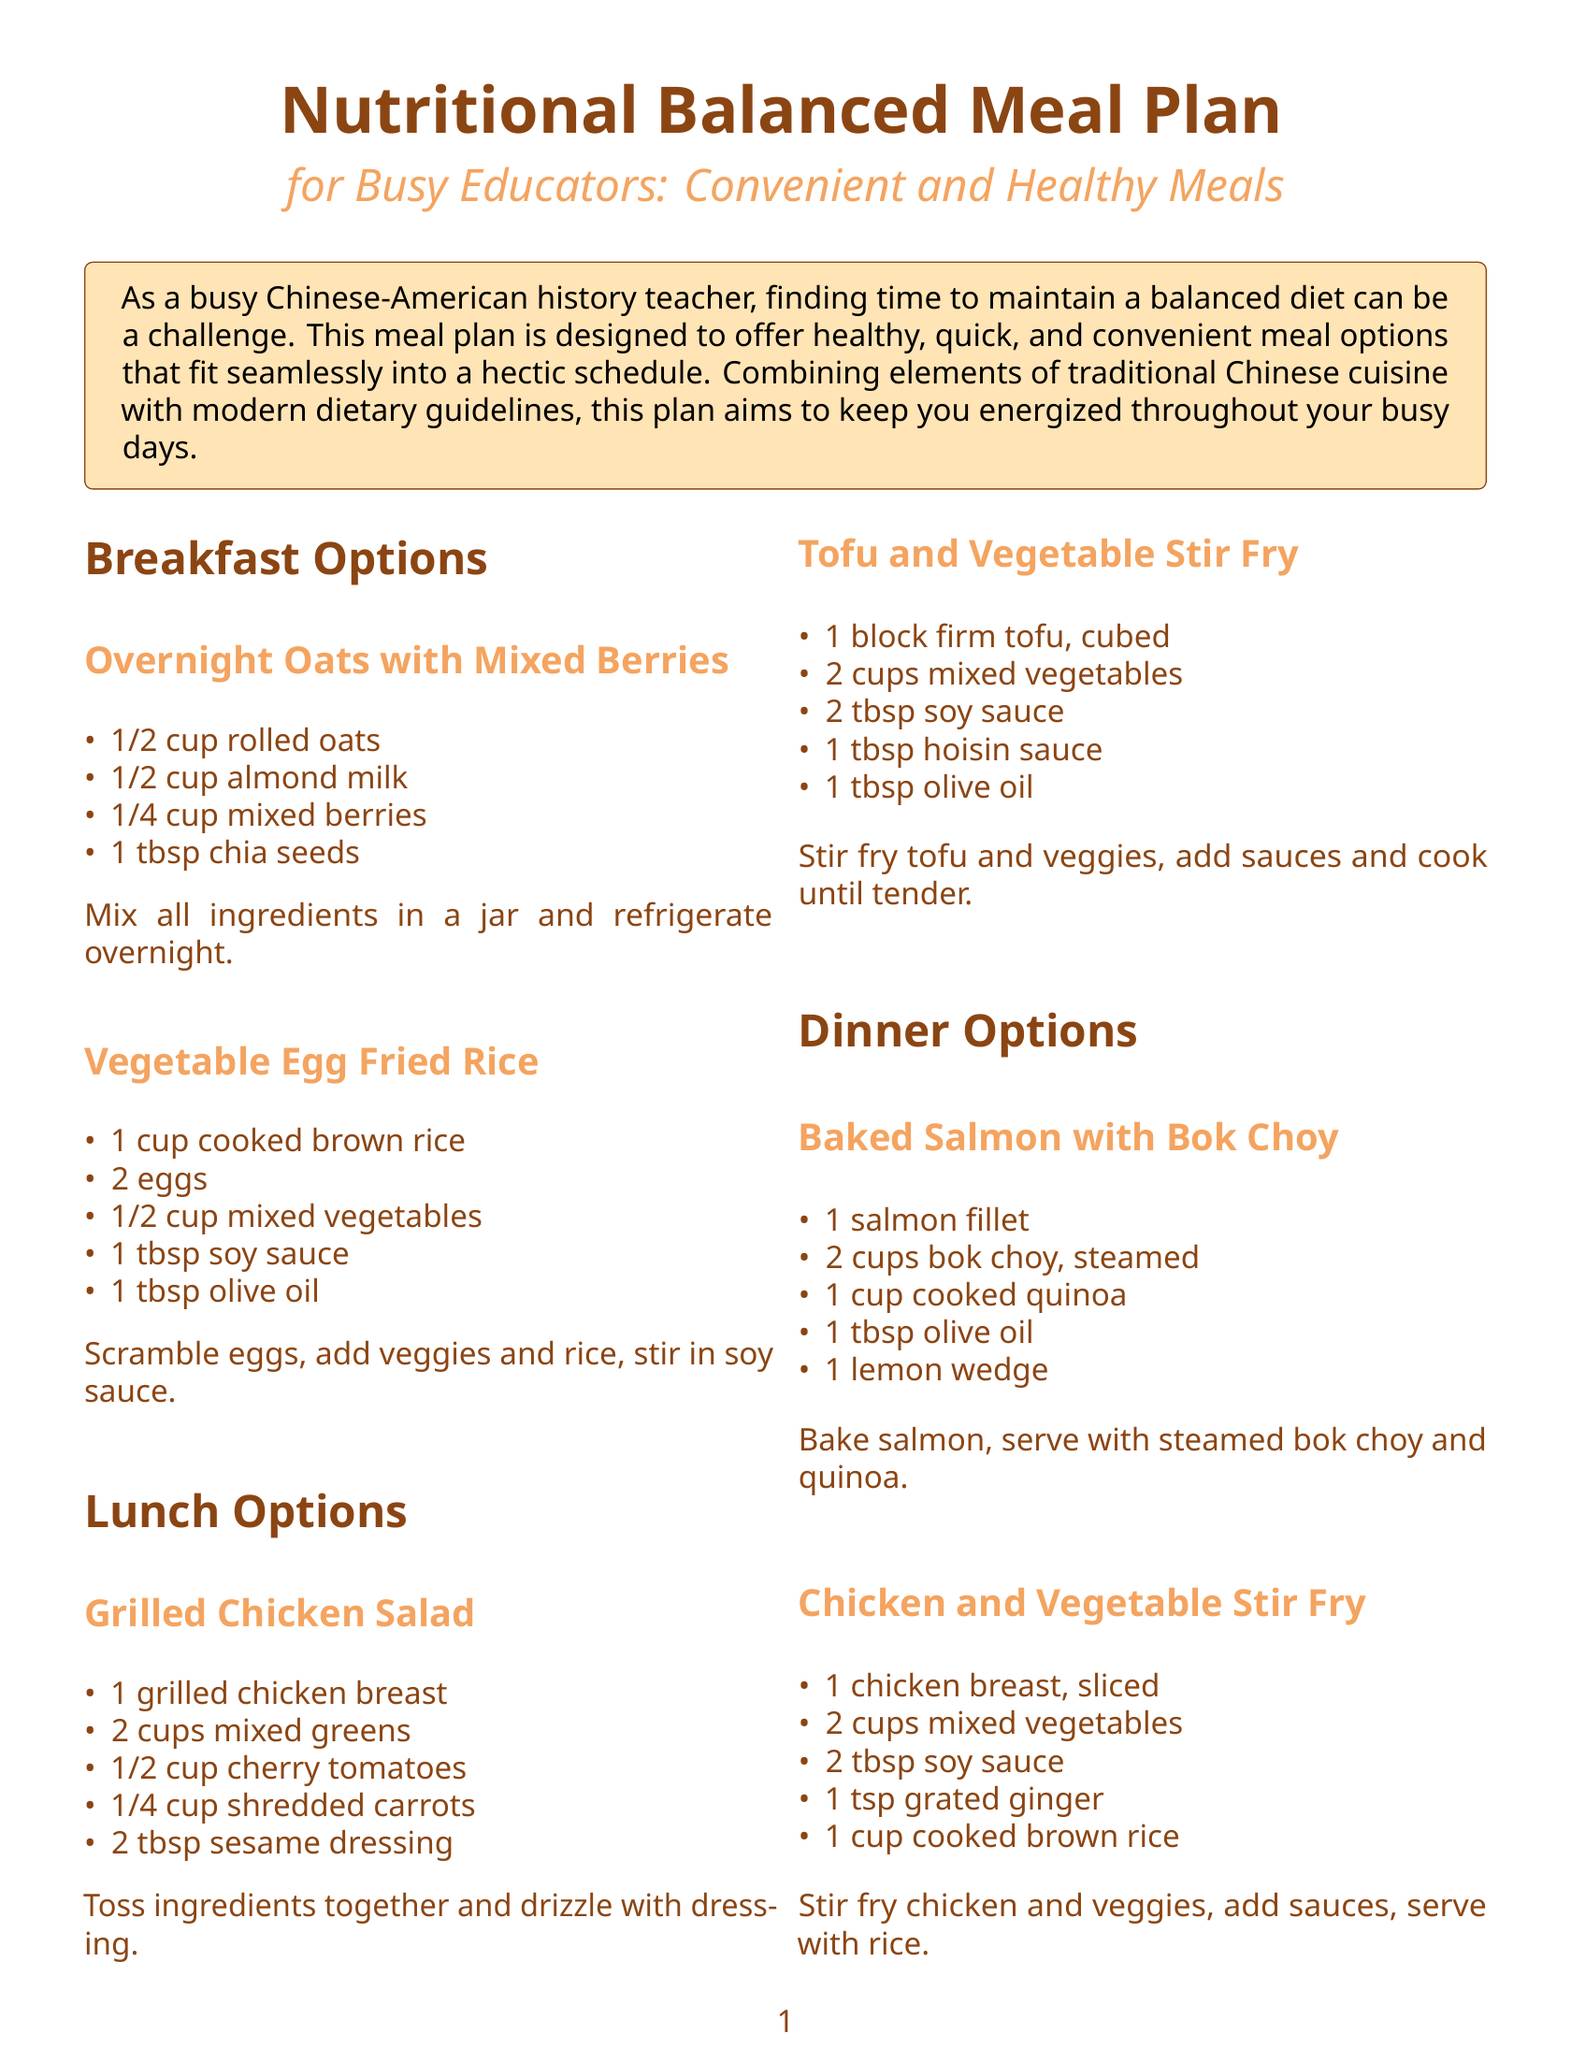What is the purpose of the meal plan? The meal plan is designed to offer healthy, quick, and convenient meal options for busy educators.
Answer: Offer healthy options How many breakfast options are provided? The document lists a total of two breakfast options.
Answer: Two What is one ingredient in the Overnight Oats with Mixed Berries? The Overnight Oats with Mixed Berries includes rolled oats as one of its ingredients.
Answer: Rolled oats How many cups of mixed vegetables are needed for the Tofu and Vegetable Stir Fry? The recipe for Tofu and Vegetable Stir Fry calls for two cups of mixed vegetables.
Answer: Two cups What is a recommended healthy snack? One of the recommended healthy snacks is an apple with peanut butter.
Answer: Apple with peanut butter What type of protein is used in the Grilled Chicken Salad? The protein source used in the Grilled Chicken Salad is grilled chicken breast.
Answer: Grilled chicken breast Which dinner option includes quinoa? The dinner option that includes quinoa is Baked Salmon with Bok Choy.
Answer: Baked Salmon with Bok Choy What is the main cooking method for the Chicken and Vegetable Stir Fry? The main cooking method for the Chicken and Vegetable Stir Fry is stir-frying.
Answer: Stir-frying 